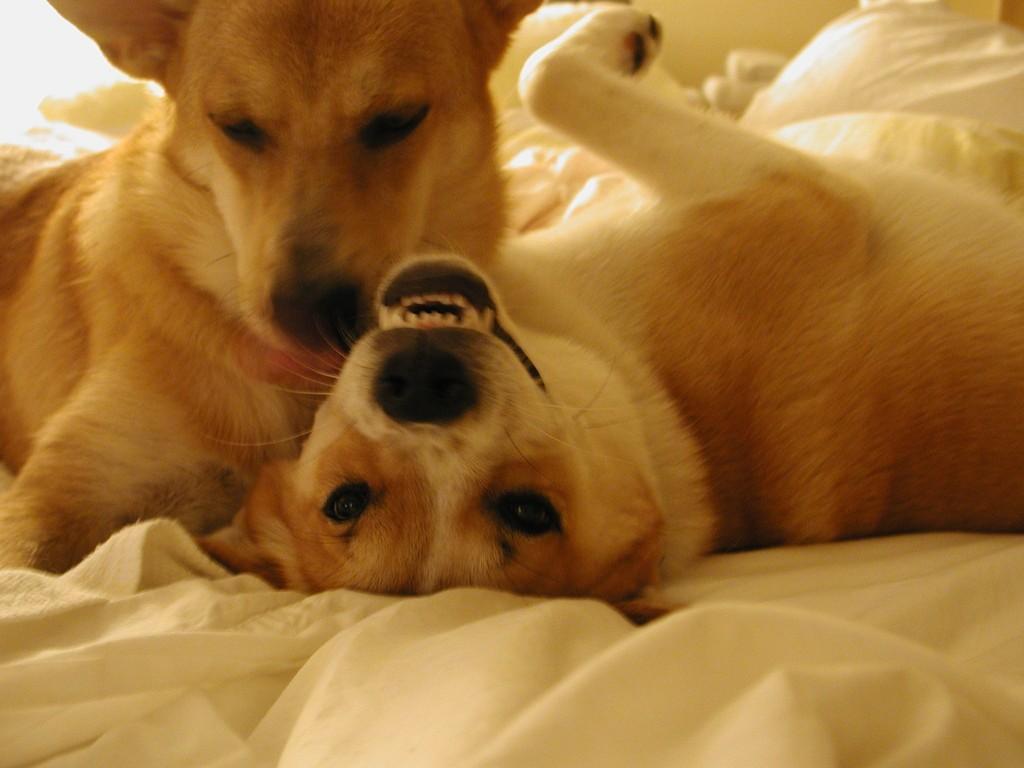Can you describe this image briefly? In this picture we can see two dogs here, at the bottom there is a cloth. 